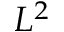Convert formula to latex. <formula><loc_0><loc_0><loc_500><loc_500>L ^ { 2 }</formula> 